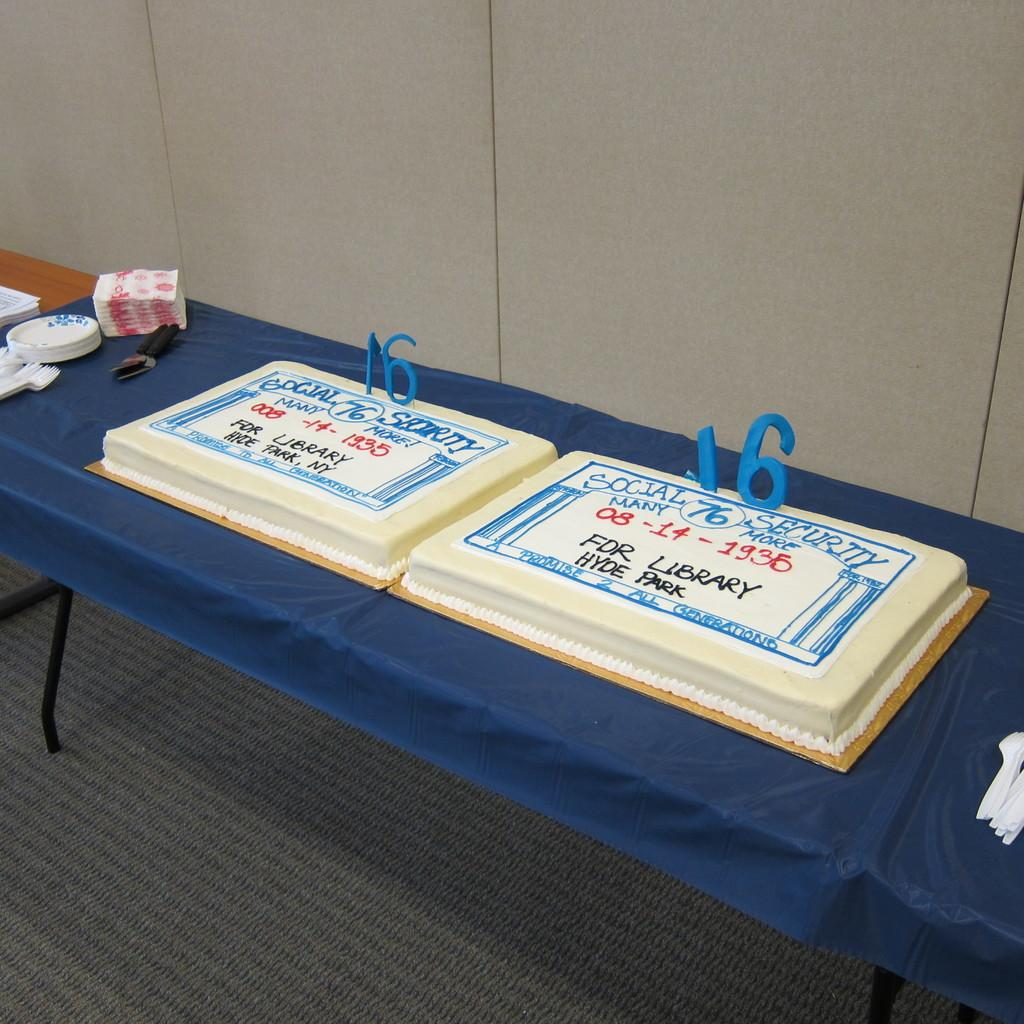What is the main piece of furniture in the image? There is a table in the image. Where is the table located? The table is on the floor. What is covering the floor? There is a cloth on the floor. What type of food can be seen in the image? There are cakes in the image. What utensils are present in the image? Knives are present in the image. What can be used for wiping or blowing one's nose in the image? Tissue papers are visible in the image. What can be used for serving food in the image? There are plates in the image. What is visible in the background of the image? There is a wall in the background of the image. What type of jeans can be seen hanging on the wall in the image? There are no jeans present in the image; only a table, cloth, cakes, knives, tissue papers, plates, and a wall are visible. 